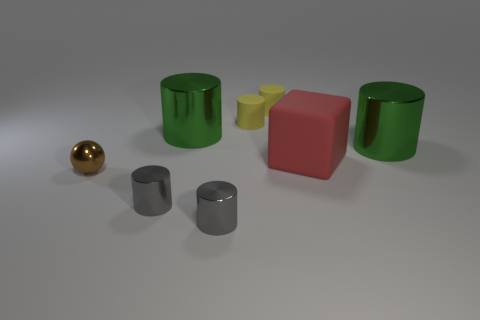Subtract all brown cylinders. Subtract all red spheres. How many cylinders are left? 6 Add 1 small yellow rubber cylinders. How many objects exist? 9 Subtract all cubes. How many objects are left? 7 Subtract 0 yellow cubes. How many objects are left? 8 Subtract all big green cylinders. Subtract all tiny gray metal cylinders. How many objects are left? 4 Add 5 yellow cylinders. How many yellow cylinders are left? 7 Add 5 small yellow matte objects. How many small yellow matte objects exist? 7 